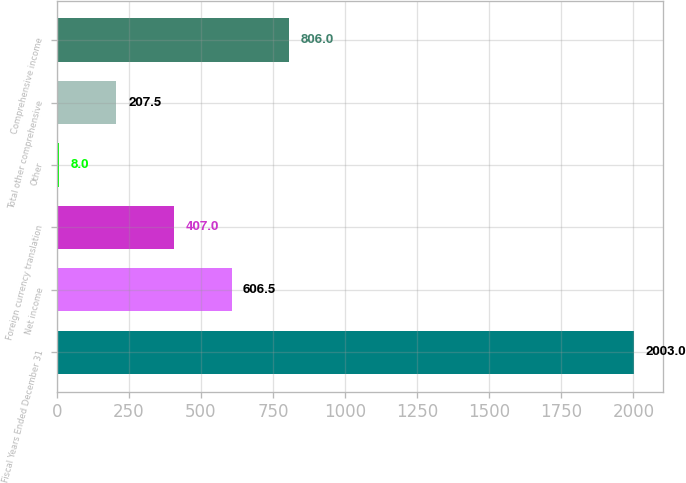Convert chart. <chart><loc_0><loc_0><loc_500><loc_500><bar_chart><fcel>Fiscal Years Ended December 31<fcel>Net income<fcel>Foreign currency translation<fcel>Other<fcel>Total other comprehensive<fcel>Comprehensive income<nl><fcel>2003<fcel>606.5<fcel>407<fcel>8<fcel>207.5<fcel>806<nl></chart> 